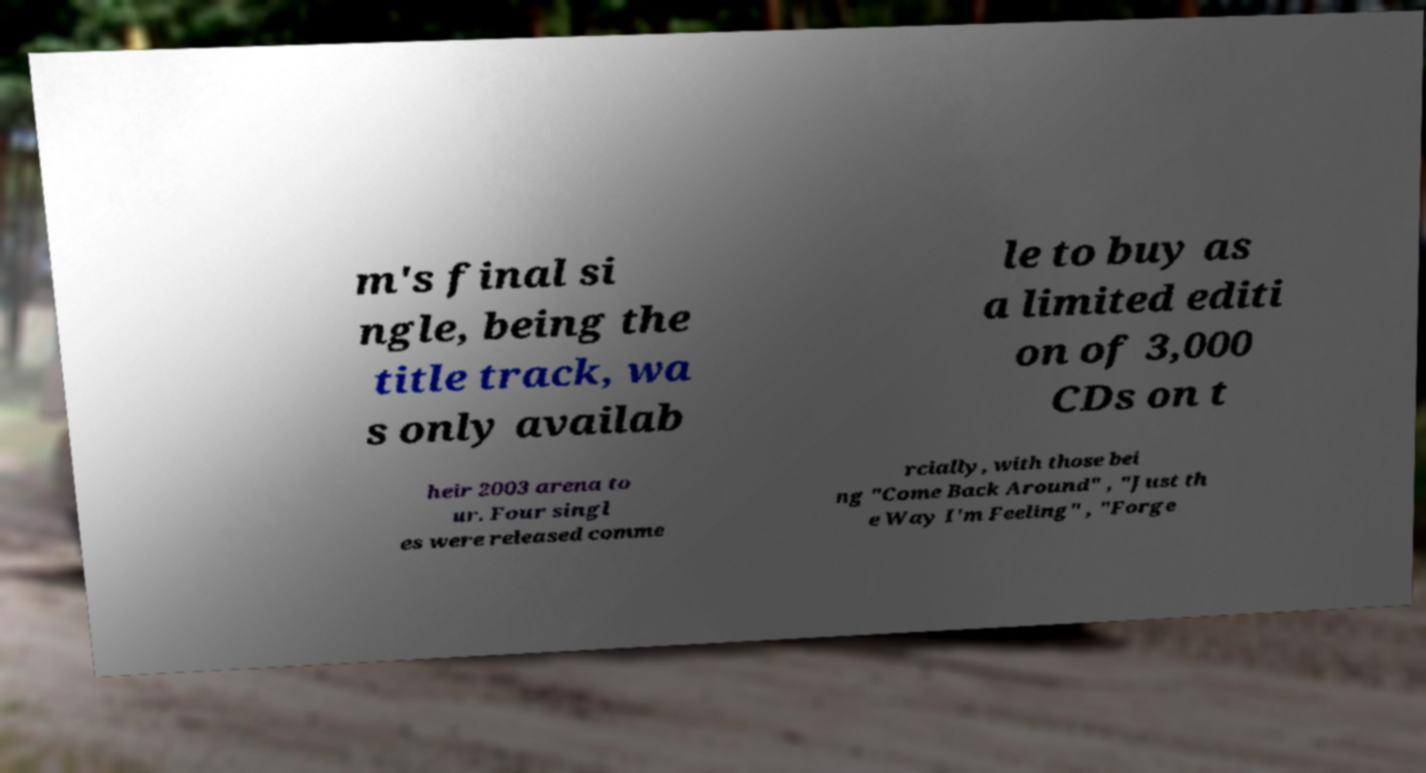Can you accurately transcribe the text from the provided image for me? m's final si ngle, being the title track, wa s only availab le to buy as a limited editi on of 3,000 CDs on t heir 2003 arena to ur. Four singl es were released comme rcially, with those bei ng "Come Back Around" , "Just th e Way I'm Feeling" , "Forge 